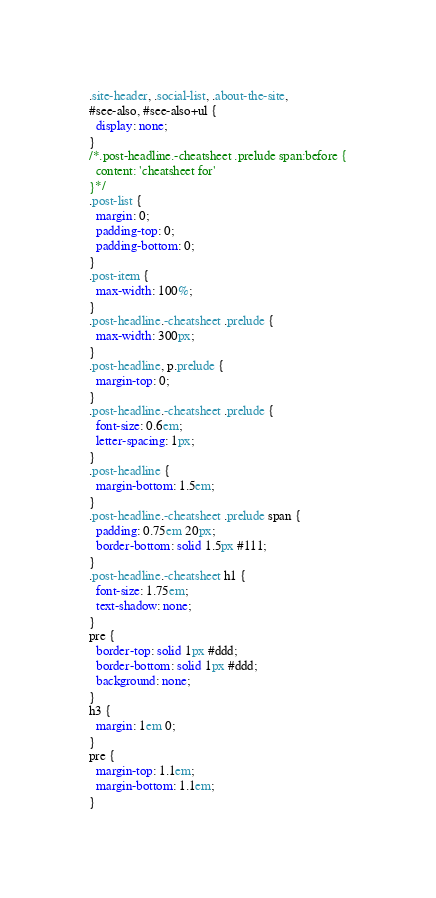<code> <loc_0><loc_0><loc_500><loc_500><_CSS_>.site-header, .social-list, .about-the-site,
#see-also, #see-also+ul {
  display: none;
}
/*.post-headline.-cheatsheet .prelude span:before {
  content: 'cheatsheet for'
}*/
.post-list {
  margin: 0;
  padding-top: 0;
  padding-bottom: 0;
}
.post-item {
  max-width: 100%;
}
.post-headline.-cheatsheet .prelude {
  max-width: 300px;
}
.post-headline, p.prelude {
  margin-top: 0;
}
.post-headline.-cheatsheet .prelude {
  font-size: 0.6em;
  letter-spacing: 1px;
}
.post-headline {
  margin-bottom: 1.5em;
}
.post-headline.-cheatsheet .prelude span {
  padding: 0.75em 20px;
  border-bottom: solid 1.5px #111;
}
.post-headline.-cheatsheet h1 {
  font-size: 1.75em;
  text-shadow: none;
}
pre {
  border-top: solid 1px #ddd;
  border-bottom: solid 1px #ddd;
  background: none;
}
h3 {
  margin: 1em 0;
}
pre {
  margin-top: 1.1em;
  margin-bottom: 1.1em;
}
</code> 